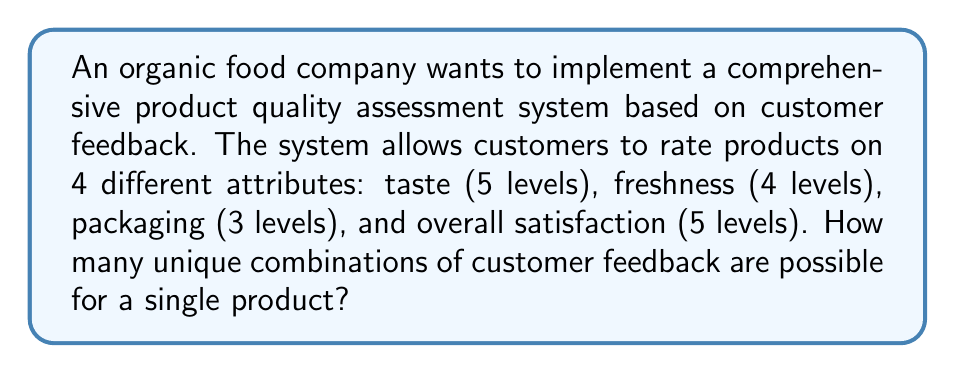Provide a solution to this math problem. To solve this problem, we need to use the multiplication principle of counting. Here's a step-by-step explanation:

1. Identify the number of options for each attribute:
   - Taste: 5 levels
   - Freshness: 4 levels
   - Packaging: 3 levels
   - Overall satisfaction: 5 levels

2. Apply the multiplication principle:
   The total number of unique combinations is the product of the number of options for each attribute.

3. Calculate the result:
   $$\text{Total combinations} = 5 \times 4 \times 3 \times 5$$

4. Compute the final answer:
   $$\text{Total combinations} = 300$$

This result represents the number of possible unique feedback combinations a customer can provide for a single product. It's important for the organic food company to consider this large number of possibilities when designing their quality assessment system and analyzing customer feedback data.
Answer: $$300 \text{ unique feedback combinations}$$ 